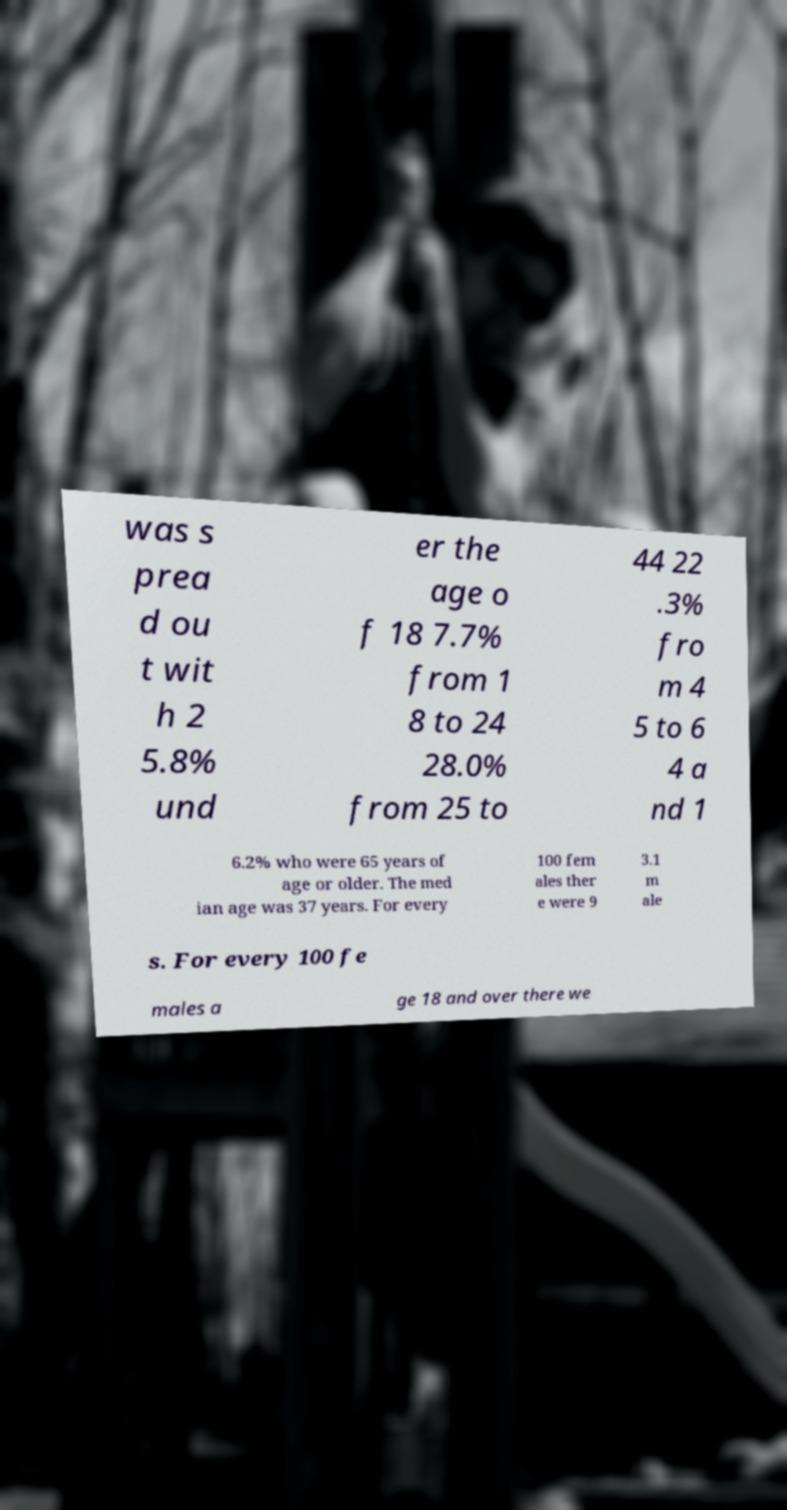What messages or text are displayed in this image? I need them in a readable, typed format. was s prea d ou t wit h 2 5.8% und er the age o f 18 7.7% from 1 8 to 24 28.0% from 25 to 44 22 .3% fro m 4 5 to 6 4 a nd 1 6.2% who were 65 years of age or older. The med ian age was 37 years. For every 100 fem ales ther e were 9 3.1 m ale s. For every 100 fe males a ge 18 and over there we 